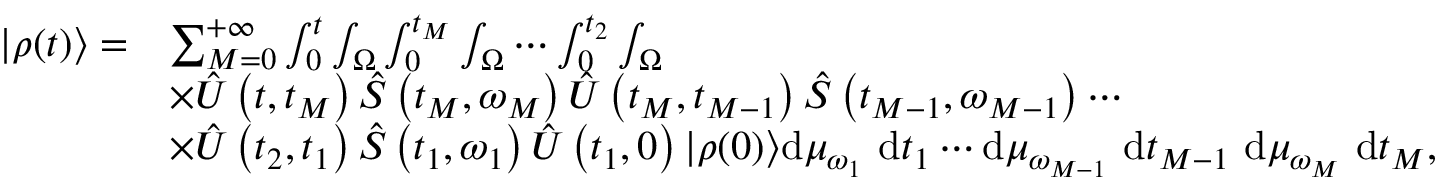<formula> <loc_0><loc_0><loc_500><loc_500>\begin{array} { r l } { | \rho ( t ) \rangle = } & { \sum _ { M = 0 } ^ { + \infty } \int _ { 0 } ^ { t } \int _ { \Omega } \int _ { 0 } ^ { t _ { M } } \int _ { \Omega } \cdots \int _ { 0 } ^ { t _ { 2 } } \int _ { \Omega } } \\ & { \times \hat { U } \left ( t , t _ { M } \right ) \hat { S } \left ( t _ { M } , \omega _ { M } \right ) \hat { U } \left ( t _ { M } , t _ { M - 1 } \right ) \hat { S } \left ( t _ { M - 1 } , \omega _ { M - 1 } \right ) \cdots } \\ & { \times \hat { U } \left ( t _ { 2 } , t _ { 1 } \right ) \hat { S } \left ( t _ { 1 } , \omega _ { 1 } \right ) \hat { U } \left ( t _ { 1 } , 0 \right ) | \rho ( 0 ) \rangle d \mu _ { \omega _ { 1 } } d t _ { 1 } \cdots d \mu _ { \omega _ { M - 1 } } d t _ { M - 1 } d \mu _ { \omega _ { M } } d t _ { M } , } \end{array}</formula> 